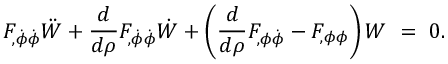<formula> <loc_0><loc_0><loc_500><loc_500>F _ { , \dot { \phi } \dot { \phi } } \ddot { W } + { \frac { d } { d \rho } } F _ { , \dot { \phi } \dot { \phi } } \dot { W } + \left ( { \frac { d } { d \rho } } F _ { , \phi \dot { \phi } } - F _ { , \phi \phi } \right ) W = 0 .</formula> 